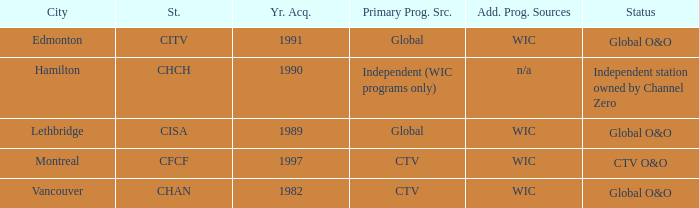How any were gained as the chan 1.0. 